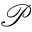<formula> <loc_0><loc_0><loc_500><loc_500>\mathcal { P }</formula> 